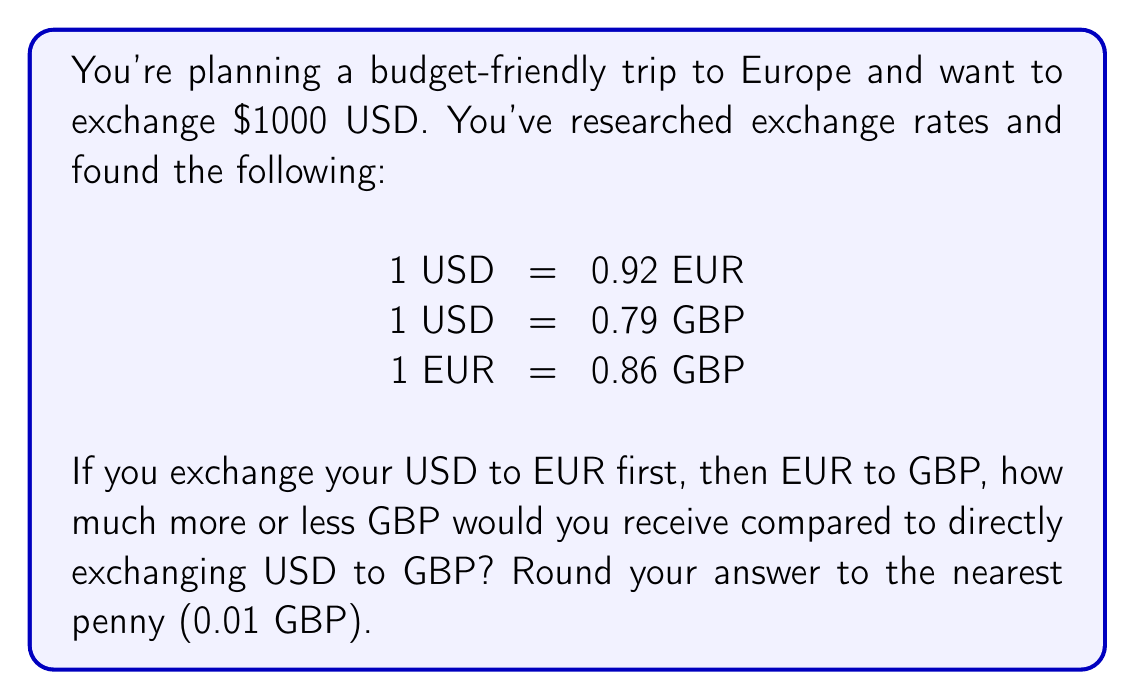Help me with this question. Let's approach this step-by-step:

1. Calculate GBP received by direct exchange:
   $$\text{USD to GBP} = 1000 \times 0.79 = 790 \text{ GBP}$$

2. Calculate EUR received from USD:
   $$\text{USD to EUR} = 1000 \times 0.92 = 920 \text{ EUR}$$

3. Convert EUR to GBP:
   $$\text{EUR to GBP} = 920 \times 0.86 = 791.20 \text{ GBP}$$

4. Calculate the difference:
   $$\text{Difference} = 791.20 - 790 = 1.20 \text{ GBP}$$

5. Round to the nearest penny:
   $$1.20 \text{ GBP} \approx 1.20 \text{ GBP}$$

Therefore, by exchanging USD to EUR first, then EUR to GBP, you would receive 1.20 GBP more than directly exchanging USD to GBP.
Answer: 1.20 GBP more 